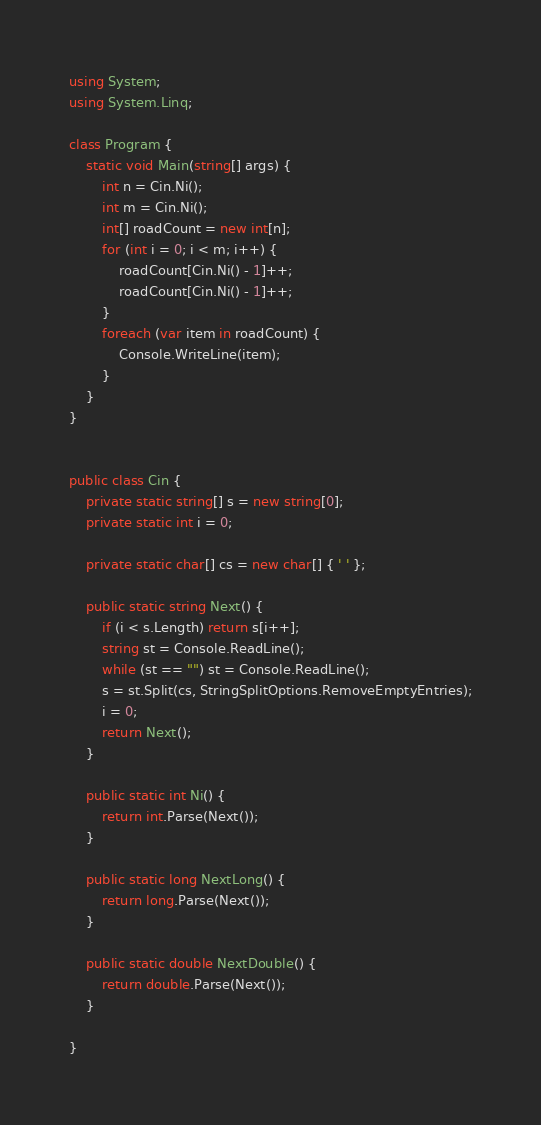<code> <loc_0><loc_0><loc_500><loc_500><_C#_>using System;
using System.Linq;

class Program {
    static void Main(string[] args) {
        int n = Cin.Ni();
        int m = Cin.Ni();
        int[] roadCount = new int[n];
        for (int i = 0; i < m; i++) {
            roadCount[Cin.Ni() - 1]++;
            roadCount[Cin.Ni() - 1]++;
        }
        foreach (var item in roadCount) {
            Console.WriteLine(item);
        }
    }
}


public class Cin {
    private static string[] s = new string[0];
    private static int i = 0;

    private static char[] cs = new char[] { ' ' };

    public static string Next() {
        if (i < s.Length) return s[i++];
        string st = Console.ReadLine();
        while (st == "") st = Console.ReadLine();
        s = st.Split(cs, StringSplitOptions.RemoveEmptyEntries);
        i = 0;
        return Next();
    }

    public static int Ni() {
        return int.Parse(Next());
    }

    public static long NextLong() {
        return long.Parse(Next());
    }

    public static double NextDouble() {
        return double.Parse(Next());
    }

}
</code> 